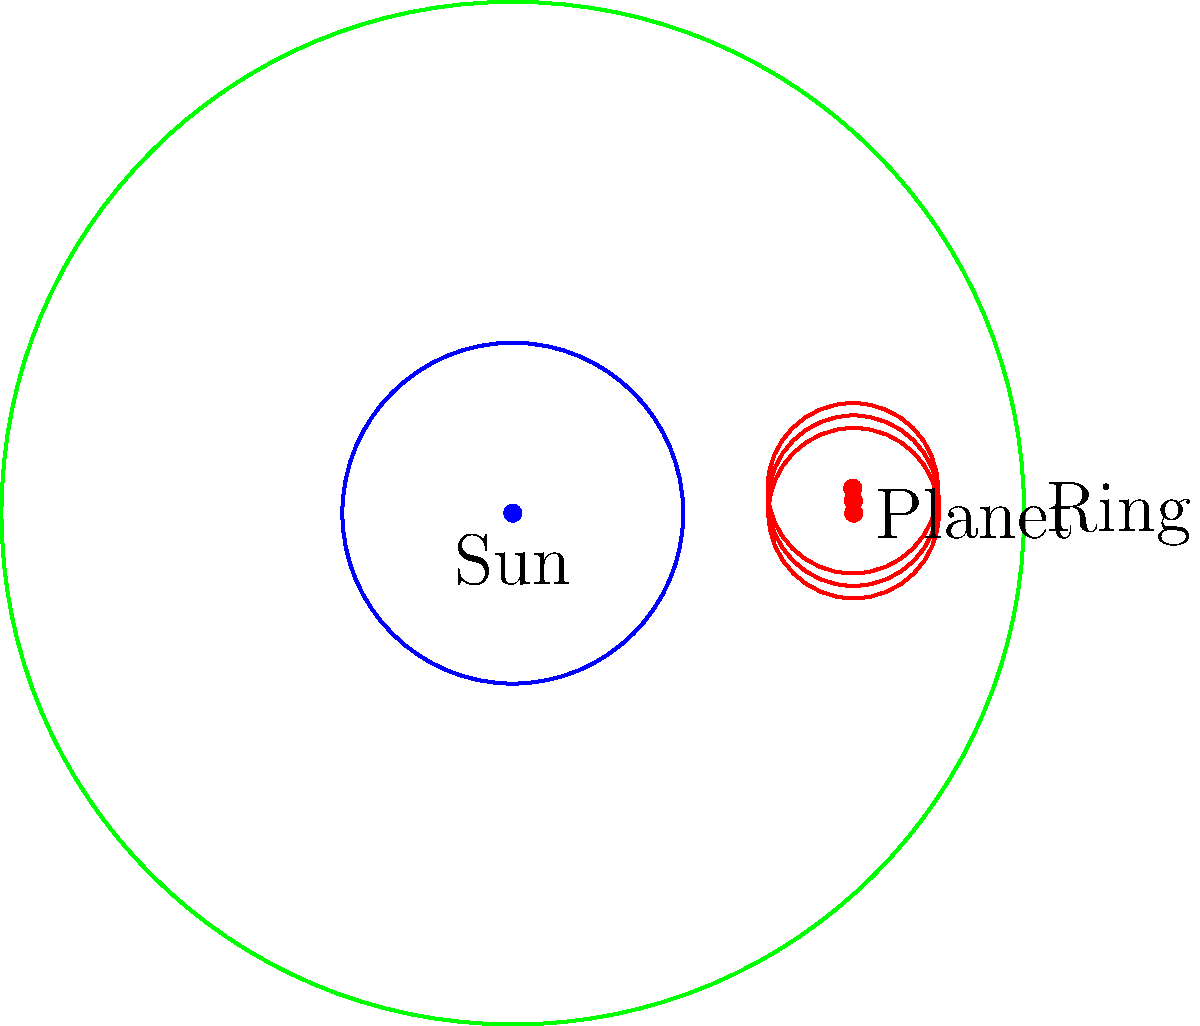In a planetary gear system with a sun gear, three equally spaced planet gears, and a ring gear, what is the order of the symmetry group for this configuration? Assume that the gears are identical in shape and size within their respective categories (sun, planet, ring). To determine the order of the symmetry group for this planetary gear system, we need to follow these steps:

1. Identify the symmetry operations:
   a) Rotational symmetry: The system can be rotated by 120° (2π/3 radians) and still look the same.
   b) Reflection symmetry: The system has three lines of reflection symmetry.

2. Calculate the number of distinct rotations:
   - 0° (identity)
   - 120°
   - 240°
   This gives us 3 rotational symmetries.

3. Count the number of reflections:
   - There are 3 lines of reflection symmetry passing through the center and each planet gear.

4. Apply the formula for the order of the dihedral group:
   The dihedral group $D_n$ has order $2n$, where $n$ is the number of rotational symmetries.
   In this case, $n = 3$, so the order is $2 \cdot 3 = 6$.

5. Verify the group elements:
   - Identity
   - Rotation by 120°
   - Rotation by 240°
   - Reflection across 3 different axes

Therefore, the symmetry group of this planetary gear system is isomorphic to the dihedral group $D_3$, which has an order of 6.
Answer: 6 